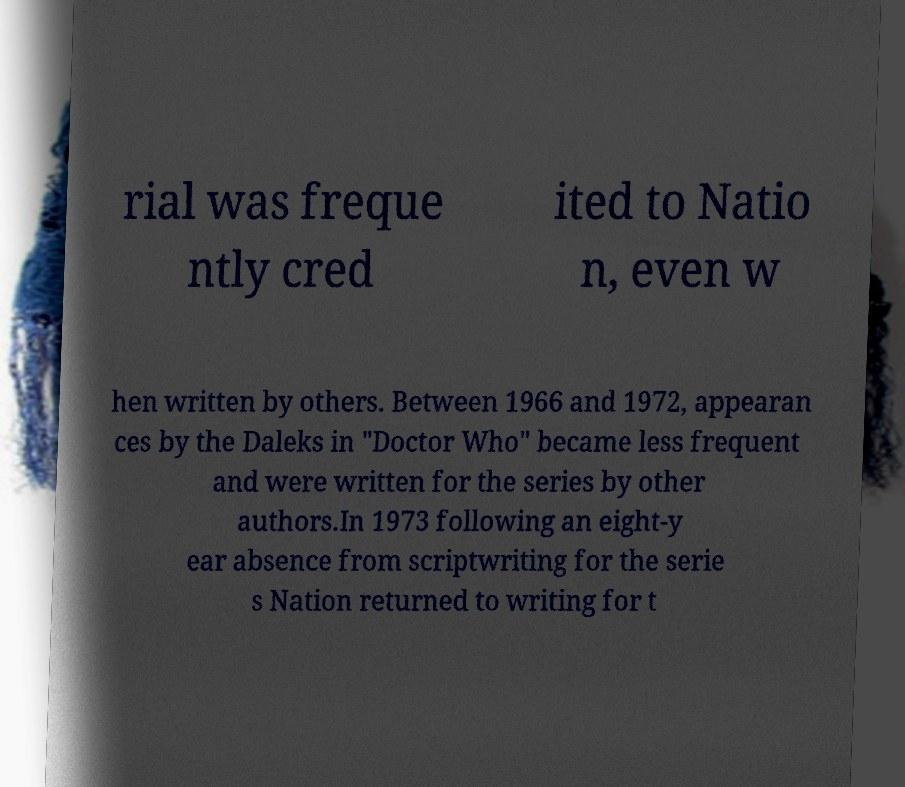Please identify and transcribe the text found in this image. rial was freque ntly cred ited to Natio n, even w hen written by others. Between 1966 and 1972, appearan ces by the Daleks in "Doctor Who" became less frequent and were written for the series by other authors.In 1973 following an eight-y ear absence from scriptwriting for the serie s Nation returned to writing for t 